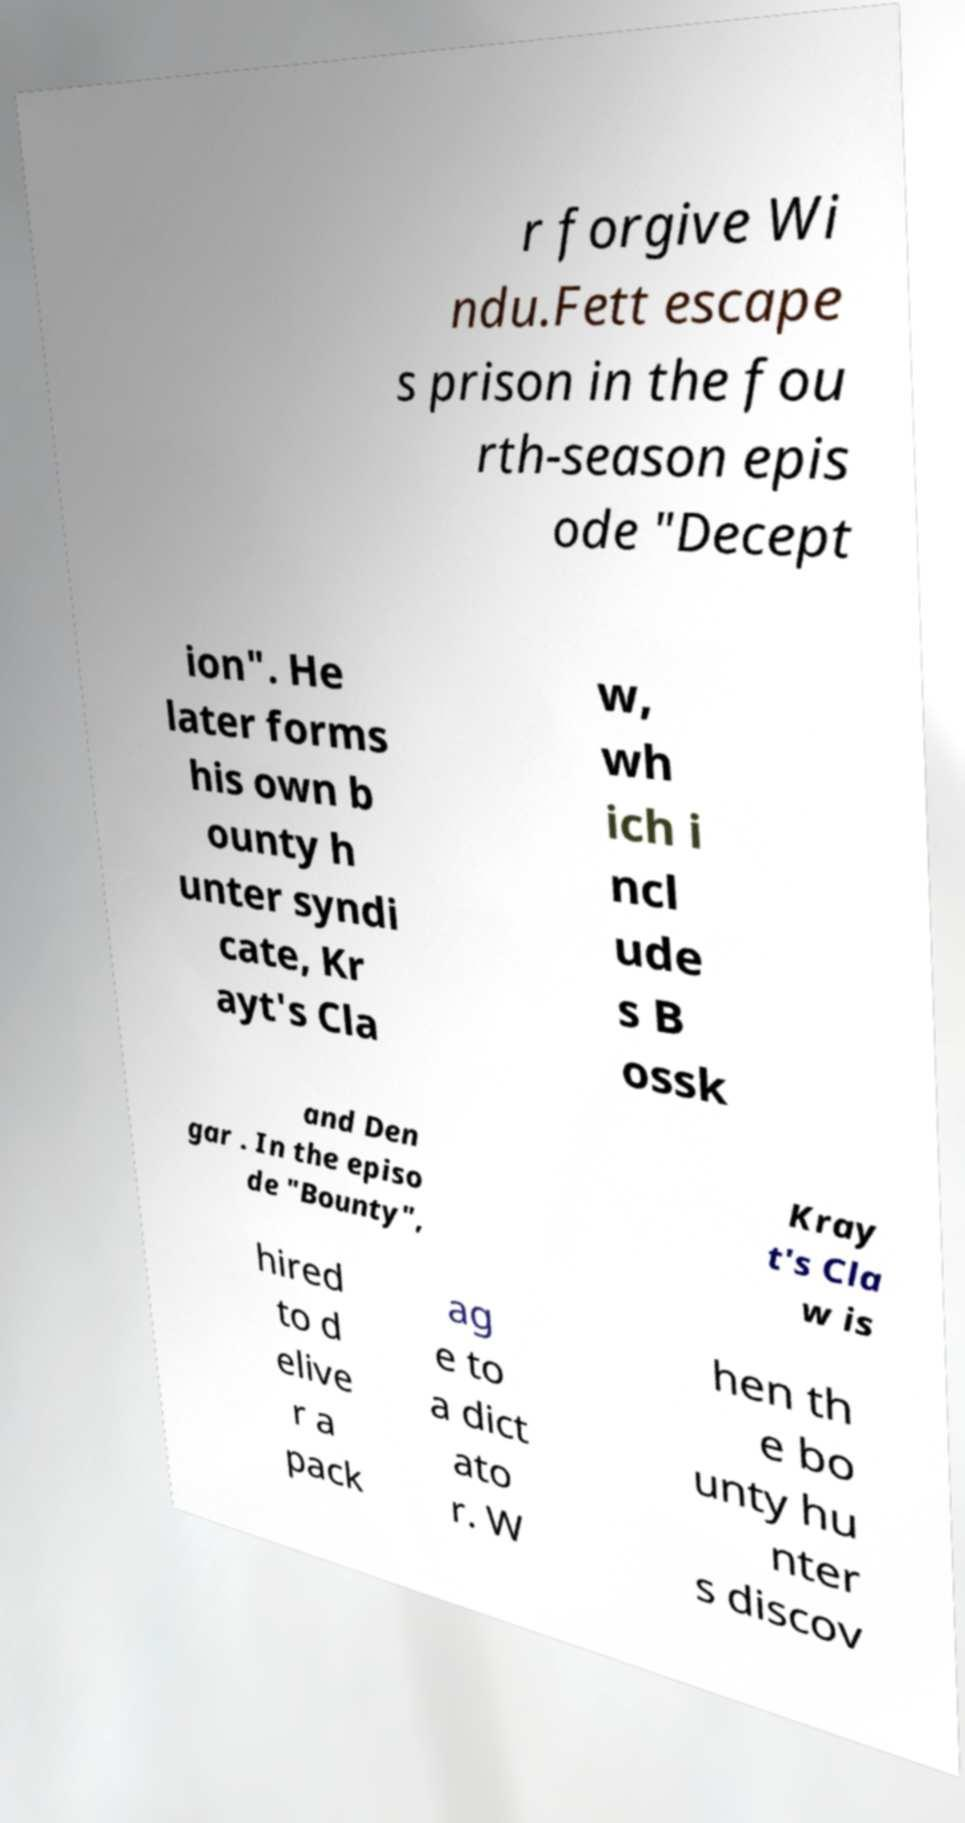What messages or text are displayed in this image? I need them in a readable, typed format. r forgive Wi ndu.Fett escape s prison in the fou rth-season epis ode "Decept ion". He later forms his own b ounty h unter syndi cate, Kr ayt's Cla w, wh ich i ncl ude s B ossk and Den gar . In the episo de "Bounty", Kray t's Cla w is hired to d elive r a pack ag e to a dict ato r. W hen th e bo unty hu nter s discov 